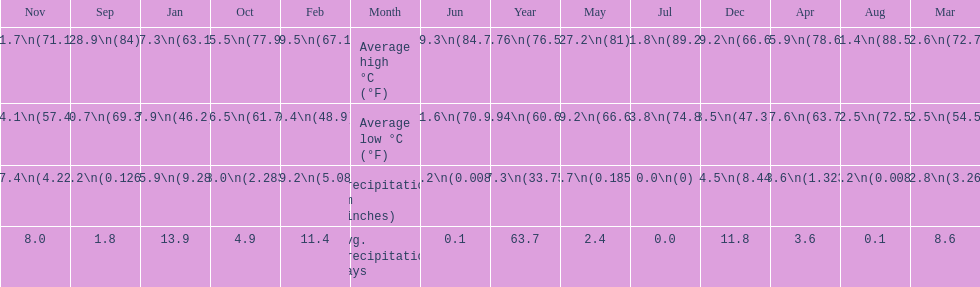What is the month with the lowest average low in haifa? January. 